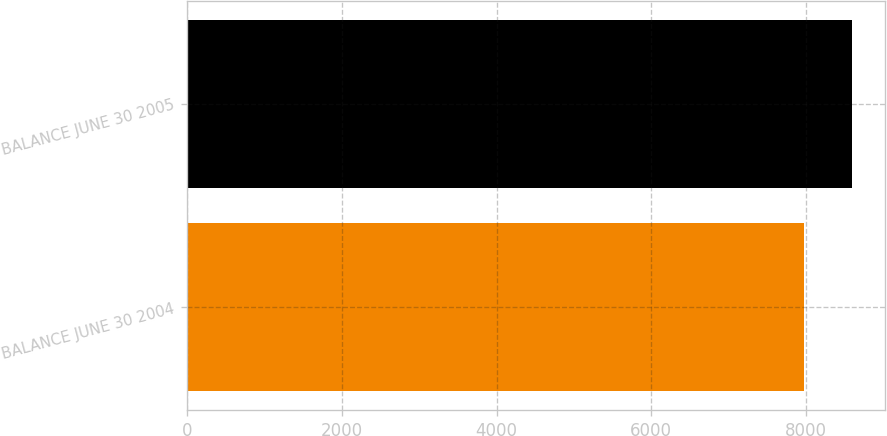<chart> <loc_0><loc_0><loc_500><loc_500><bar_chart><fcel>BALANCE JUNE 30 2004<fcel>BALANCE JUNE 30 2005<nl><fcel>7976.3<fcel>8593<nl></chart> 